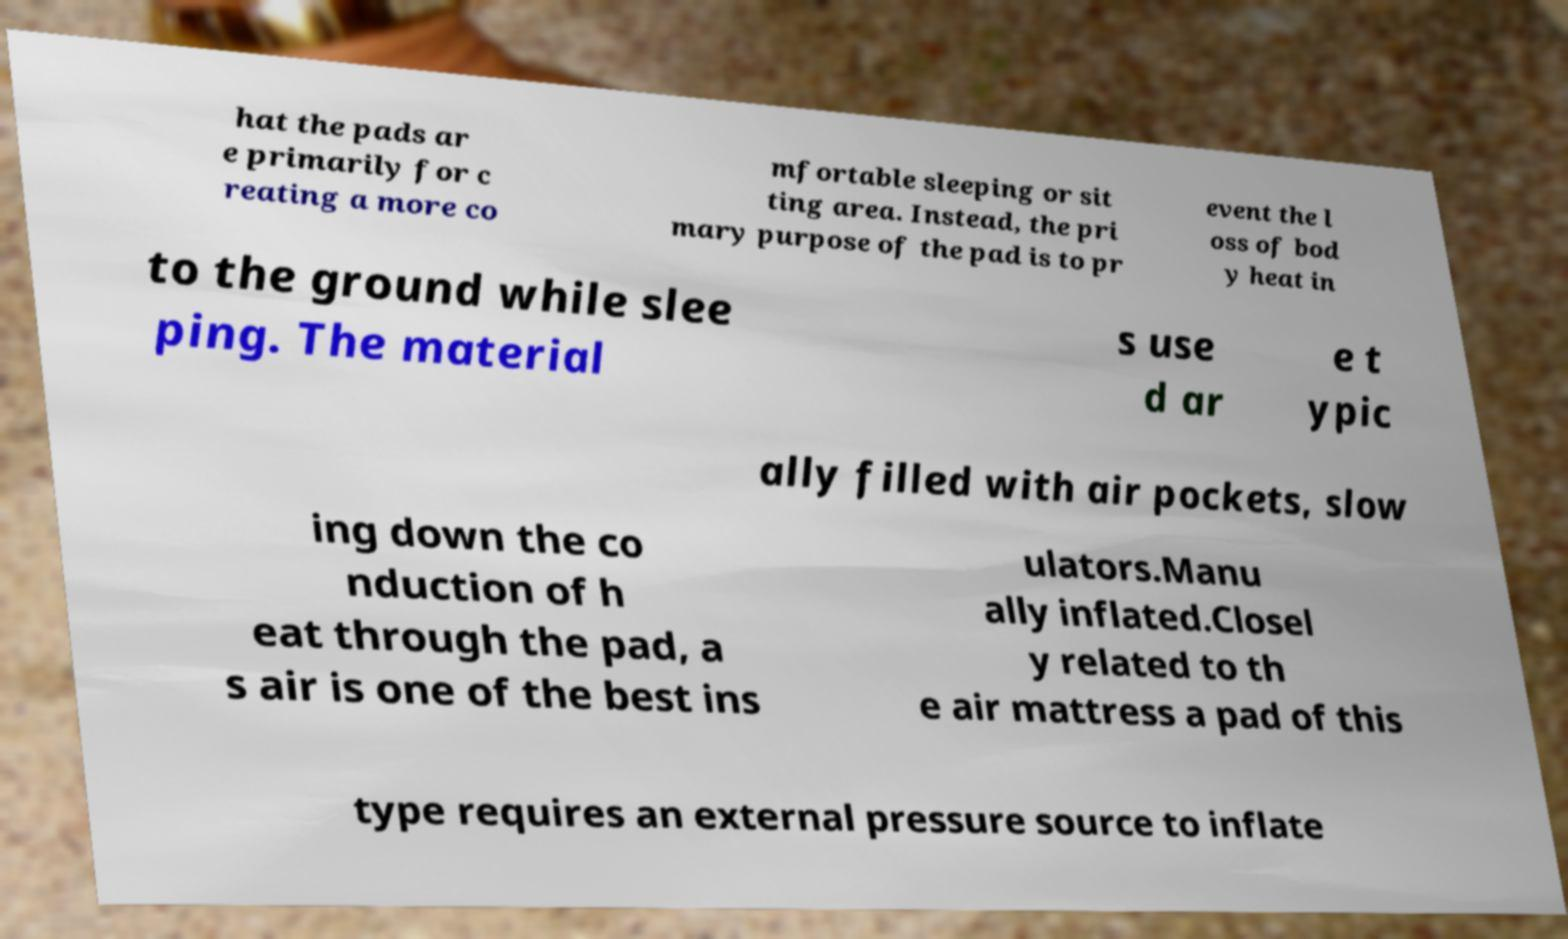There's text embedded in this image that I need extracted. Can you transcribe it verbatim? hat the pads ar e primarily for c reating a more co mfortable sleeping or sit ting area. Instead, the pri mary purpose of the pad is to pr event the l oss of bod y heat in to the ground while slee ping. The material s use d ar e t ypic ally filled with air pockets, slow ing down the co nduction of h eat through the pad, a s air is one of the best ins ulators.Manu ally inflated.Closel y related to th e air mattress a pad of this type requires an external pressure source to inflate 